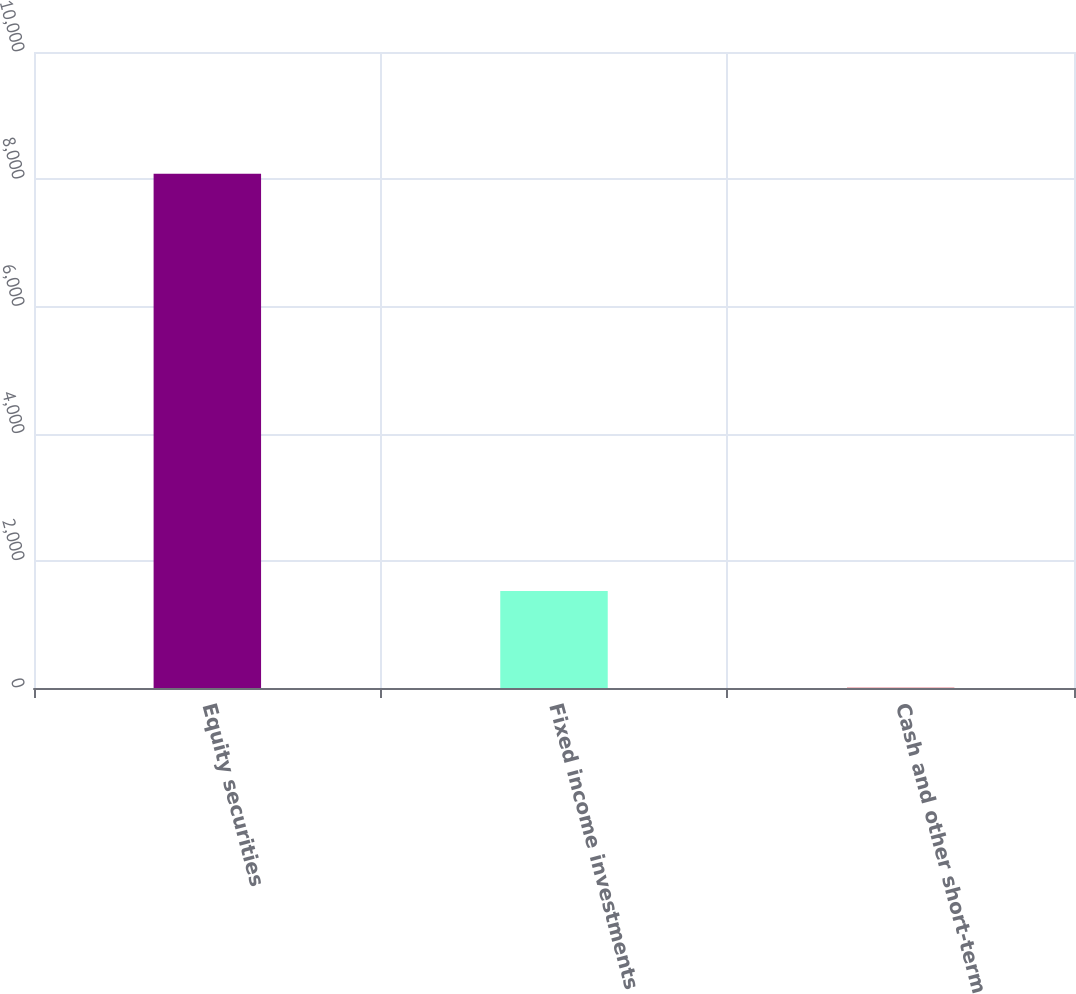Convert chart. <chart><loc_0><loc_0><loc_500><loc_500><bar_chart><fcel>Equity securities<fcel>Fixed income investments<fcel>Cash and other short-term<nl><fcel>8085<fcel>1525<fcel>5<nl></chart> 